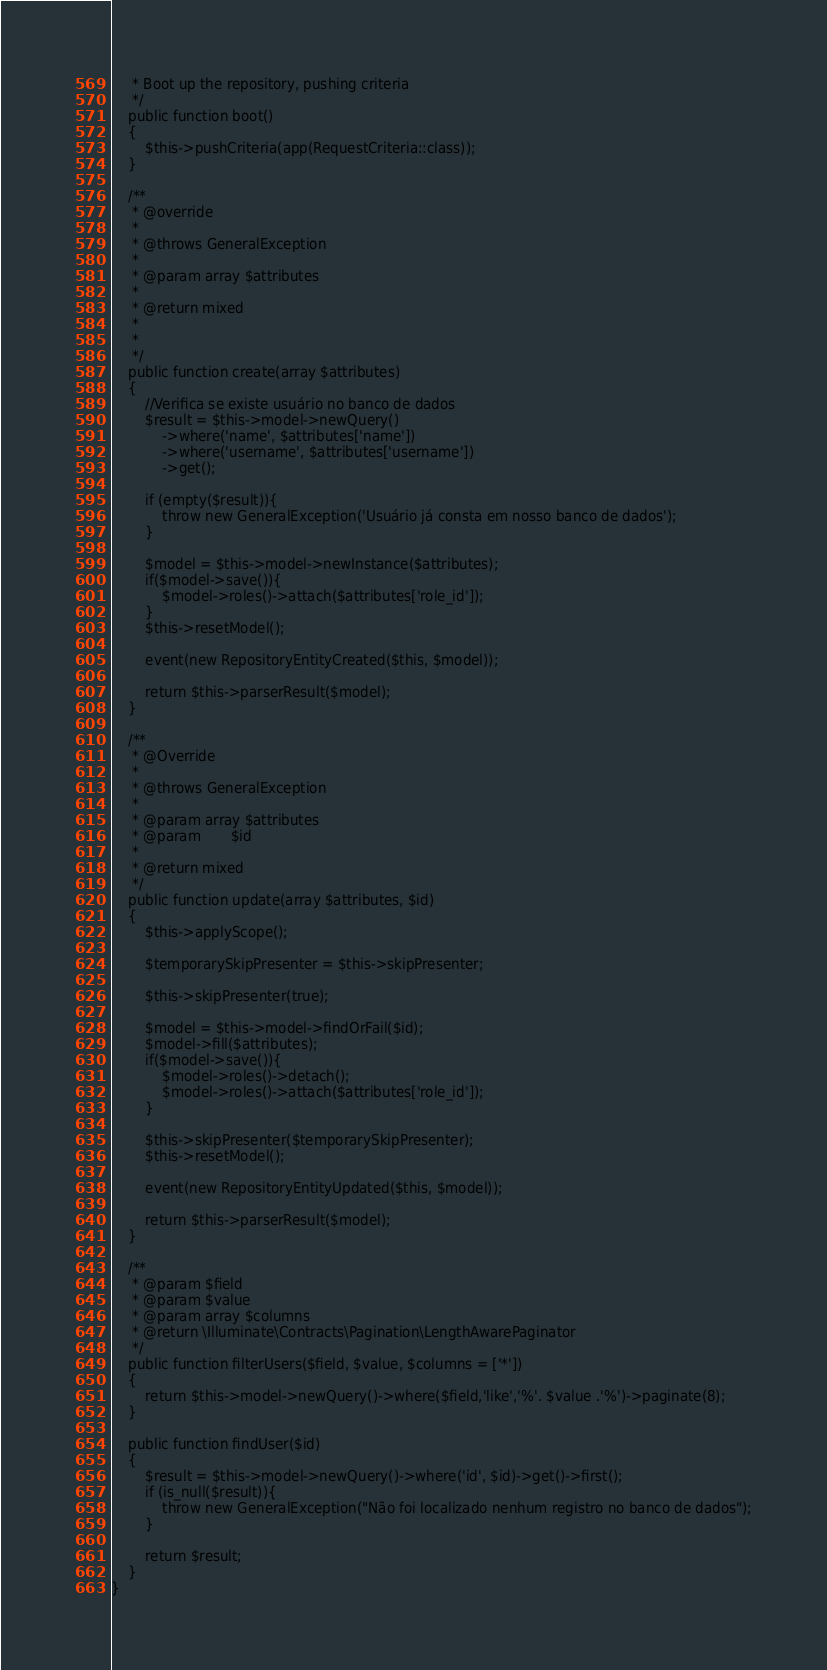<code> <loc_0><loc_0><loc_500><loc_500><_PHP_>     * Boot up the repository, pushing criteria
     */
    public function boot()
    {
        $this->pushCriteria(app(RequestCriteria::class));
    }

    /**
     * @override
     *
     * @throws GeneralException
     *
     * @param array $attributes
     *
     * @return mixed
     *
     *
     */
    public function create(array $attributes)
    {
        //Verifica se existe usuário no banco de dados
        $result = $this->model->newQuery()
            ->where('name', $attributes['name'])
            ->where('username', $attributes['username'])
            ->get();

        if (empty($result)){
            throw new GeneralException('Usuário já consta em nosso banco de dados');
        }

        $model = $this->model->newInstance($attributes);
        if($model->save()){
            $model->roles()->attach($attributes['role_id']);
        }
        $this->resetModel();

        event(new RepositoryEntityCreated($this, $model));

        return $this->parserResult($model);
    }

    /**
     * @Override
     *
     * @throws GeneralException
     *
     * @param array $attributes
     * @param       $id
     *
     * @return mixed
     */
    public function update(array $attributes, $id)
    {
        $this->applyScope();

        $temporarySkipPresenter = $this->skipPresenter;

        $this->skipPresenter(true);

        $model = $this->model->findOrFail($id);
        $model->fill($attributes);
        if($model->save()){
            $model->roles()->detach();
            $model->roles()->attach($attributes['role_id']);
        }

        $this->skipPresenter($temporarySkipPresenter);
        $this->resetModel();

        event(new RepositoryEntityUpdated($this, $model));

        return $this->parserResult($model);
    }

    /**
     * @param $field
     * @param $value
     * @param array $columns
     * @return \Illuminate\Contracts\Pagination\LengthAwarePaginator
     */
    public function filterUsers($field, $value, $columns = ['*'])
    {
        return $this->model->newQuery()->where($field,'like','%'. $value .'%')->paginate(8);
    }

    public function findUser($id)
    {
        $result = $this->model->newQuery()->where('id', $id)->get()->first();
        if (is_null($result)){
            throw new GeneralException("Não foi localizado nenhum registro no banco de dados");
        }

        return $result;
    }
}
</code> 